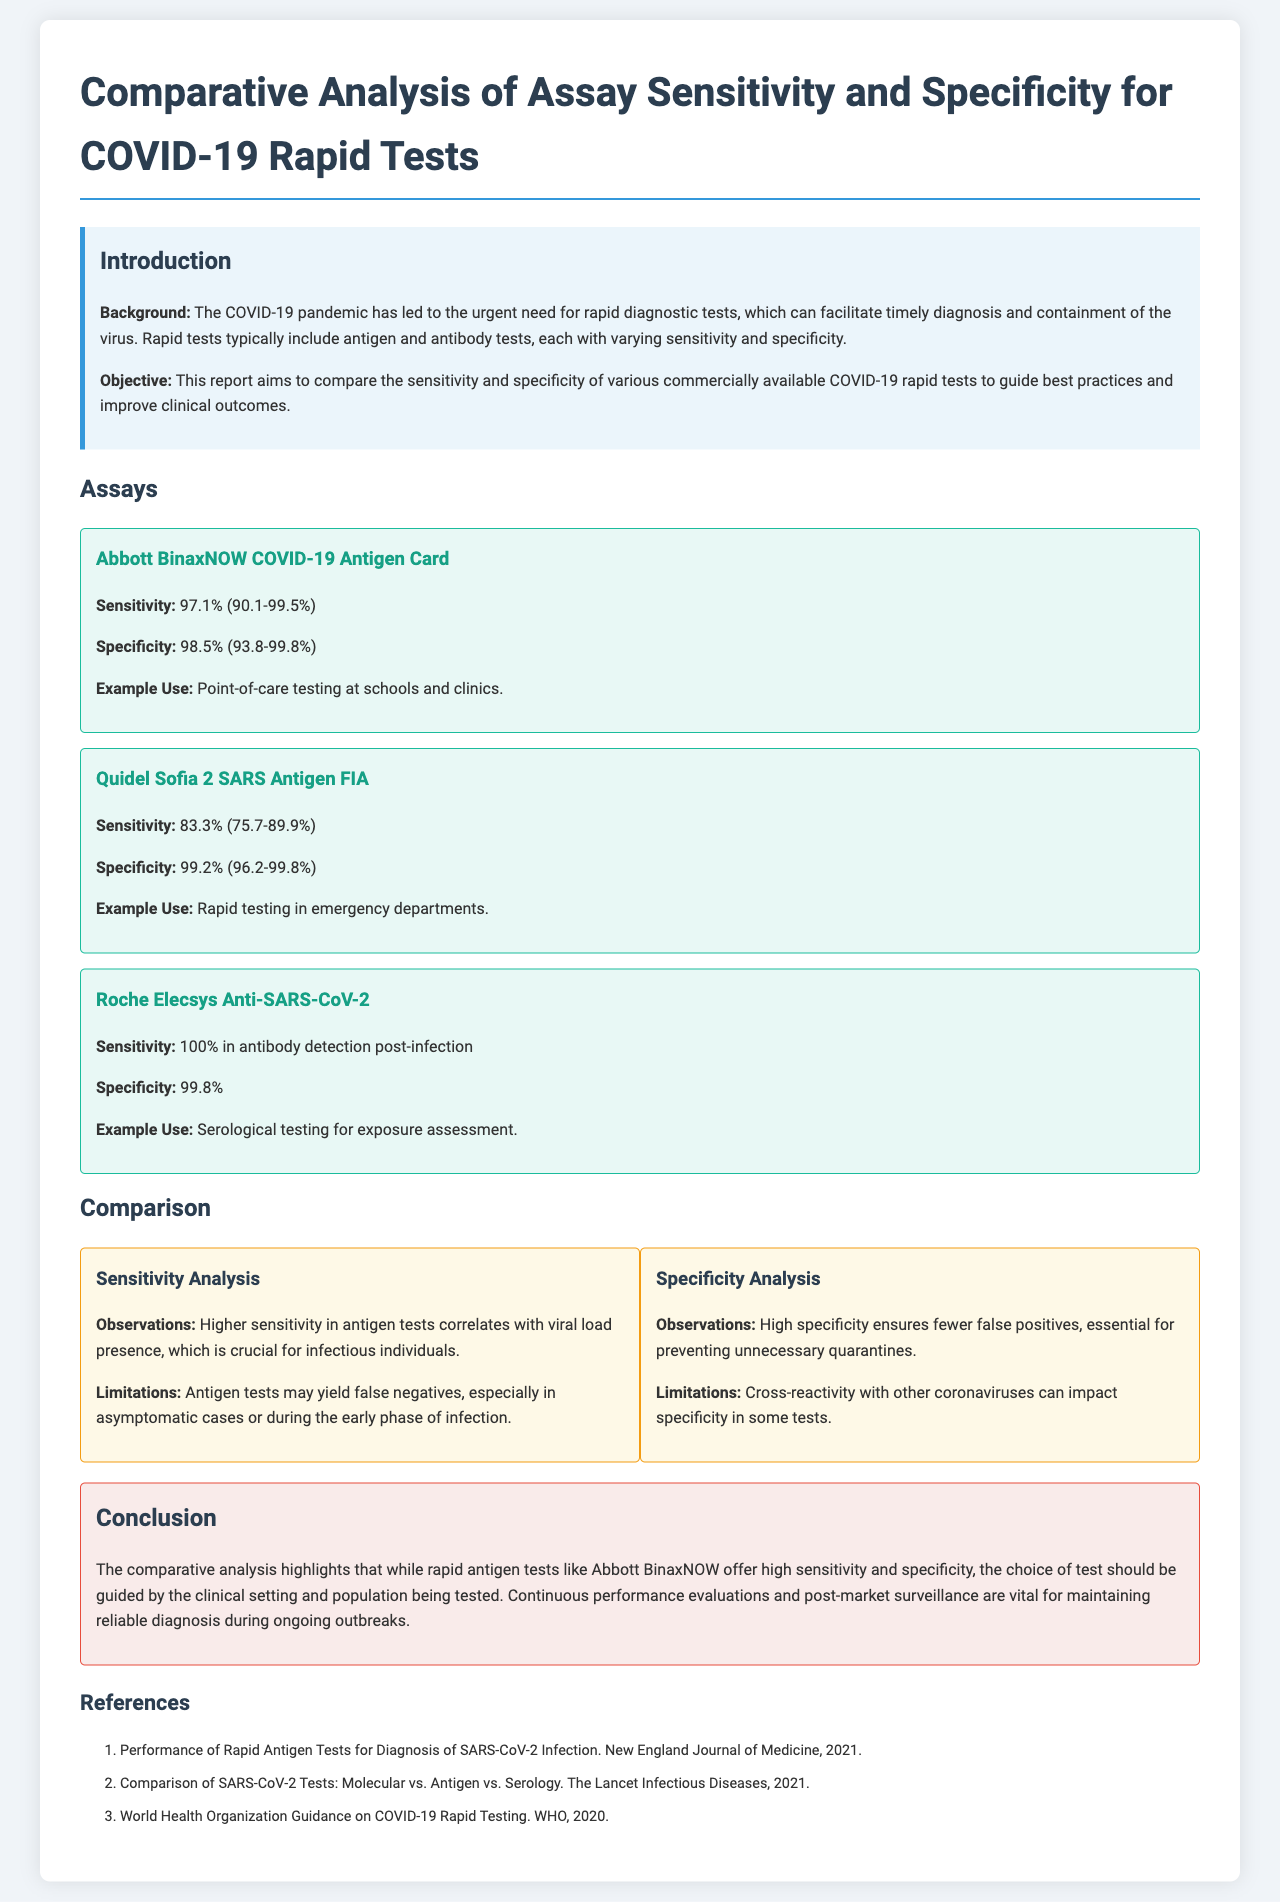What is the title of the report? The title is stated at the beginning of the document as a heading.
Answer: Comparative Analysis of Assay Sensitivity and Specificity for COVID-19 Rapid Tests What is the sensitivity of the Abbott BinaxNOW COVID-19 Antigen Card? The sensitivity is provided in the assay section focusing on Abbott BinaxNOW.
Answer: 97.1% (90.1-99.5%) What is the specificity of the Quidel Sofia 2 SARS Antigen FIA? The specificity is detailed in the assay section specifically for Quidel Sofia 2.
Answer: 99.2% (96.2-99.8%) What does the Roche Elecsys Anti-SARS-CoV-2 assay measure? The document specifies the kind of testing the Roche Elecsys assay is used for.
Answer: Serological testing for exposure assessment What is one limitation mentioned for antigen tests? Limitations are discussed in the sensitivity analysis section regarding antigen tests.
Answer: False negatives What is one strength of high specificity in tests? The observations on specificity explain its strengths in the document.
Answer: Preventing unnecessary quarantines What does the conclusion stress about test choice? The conclusion reflects on the considerations for selecting tests based on certain criteria.
Answer: Guided by the clinical setting What type of testing does the Abbott BinaxNOW facilitate? The example use section indicates the context in which Abbott BinaxNOW is used.
Answer: Point-of-care testing at schools and clinics 